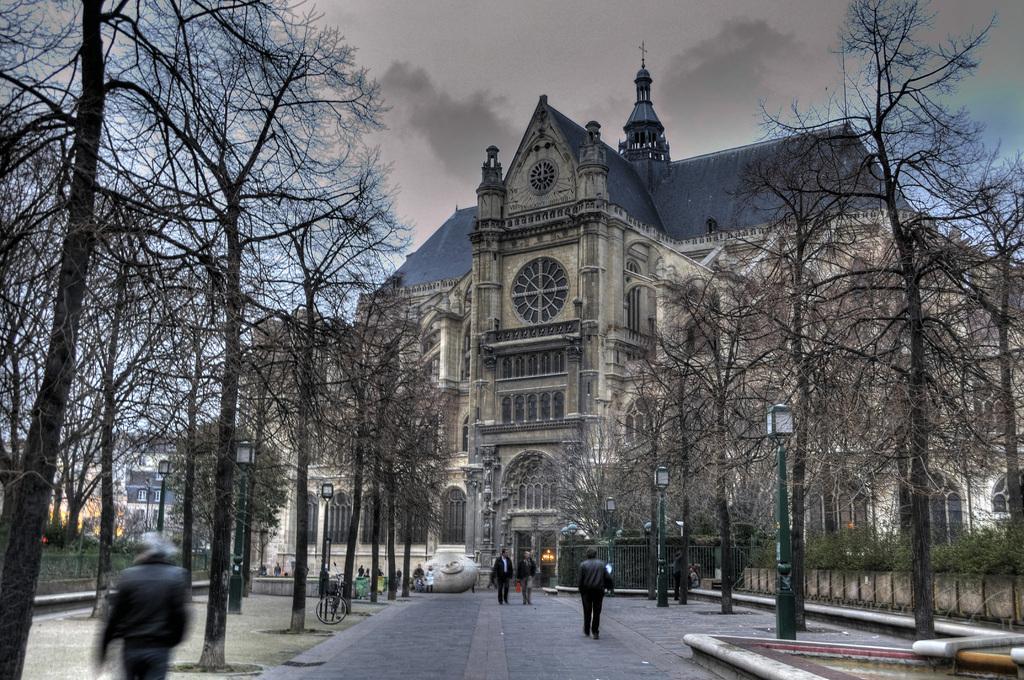Describe this image in one or two sentences. This is an outside view. At the bottom of the image I can see the road. In the background there are many people walking on the road. On both sides of the road I can see the trees. In the background there is a building. At the top I can see the sky. 